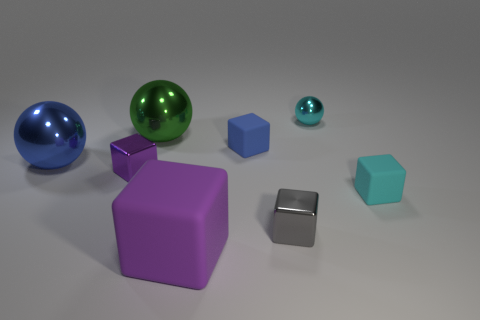Subtract 2 cubes. How many cubes are left? 3 Subtract all cyan blocks. Subtract all brown spheres. How many blocks are left? 4 Add 1 small blue blocks. How many objects exist? 9 Subtract all balls. How many objects are left? 5 Add 5 small cyan matte blocks. How many small cyan matte blocks are left? 6 Add 7 small gray blocks. How many small gray blocks exist? 8 Subtract 1 gray cubes. How many objects are left? 7 Subtract all big shiny objects. Subtract all tiny metal balls. How many objects are left? 5 